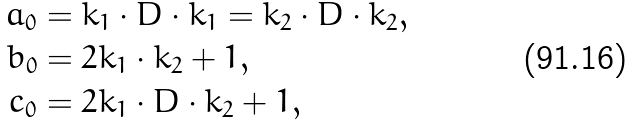<formula> <loc_0><loc_0><loc_500><loc_500>a _ { 0 } & = k _ { 1 } \cdot D \cdot k _ { 1 } = k _ { 2 } \cdot D \cdot k _ { 2 } , \\ b _ { 0 } & = 2 k _ { 1 } \cdot k _ { 2 } + 1 , \\ c _ { 0 } & = 2 k _ { 1 } \cdot D \cdot k _ { 2 } + 1 ,</formula> 